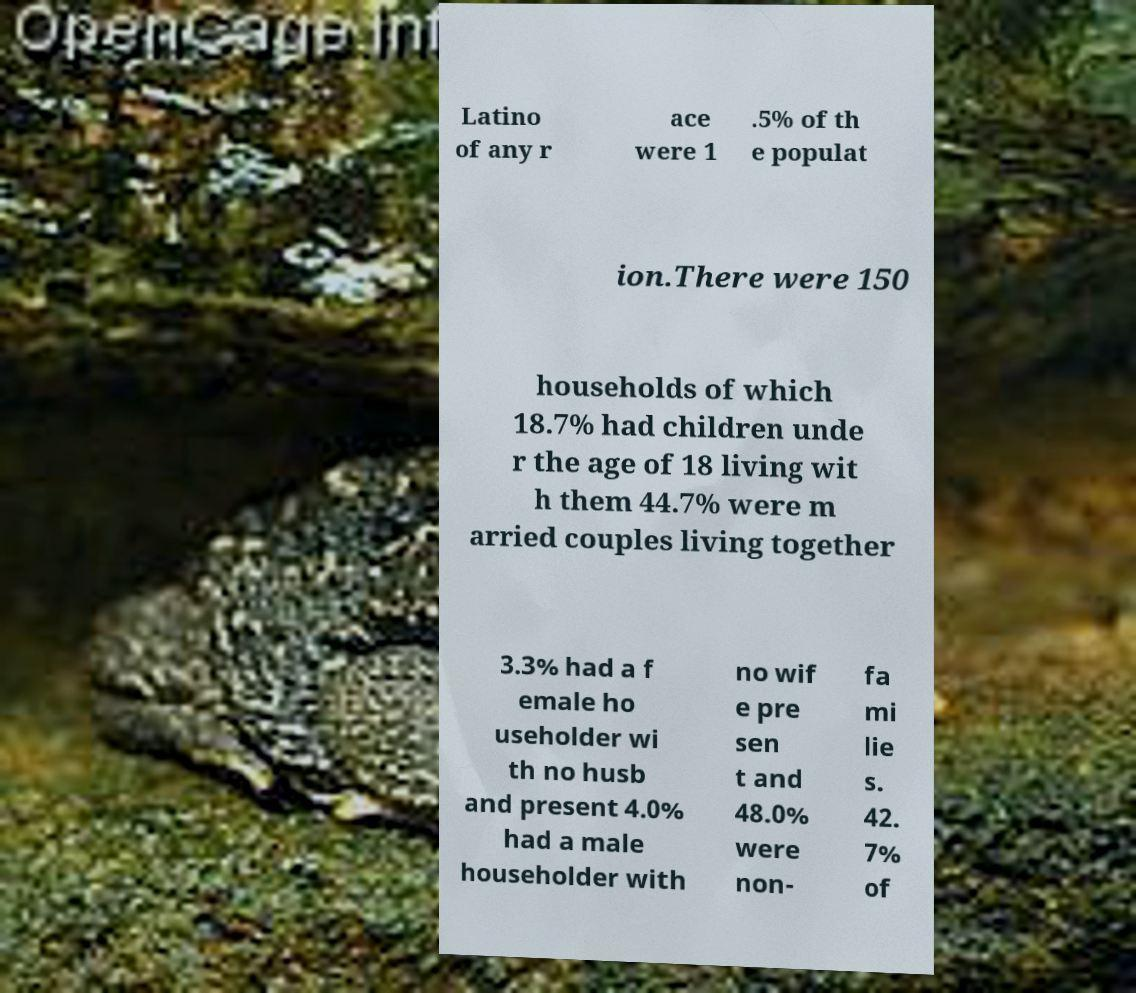I need the written content from this picture converted into text. Can you do that? Latino of any r ace were 1 .5% of th e populat ion.There were 150 households of which 18.7% had children unde r the age of 18 living wit h them 44.7% were m arried couples living together 3.3% had a f emale ho useholder wi th no husb and present 4.0% had a male householder with no wif e pre sen t and 48.0% were non- fa mi lie s. 42. 7% of 